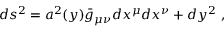Convert formula to latex. <formula><loc_0><loc_0><loc_500><loc_500>d s ^ { 2 } = a ^ { 2 } ( y ) \bar { g } _ { \mu \nu } d x ^ { \mu } d x ^ { \nu } + d y ^ { 2 } \ ,</formula> 